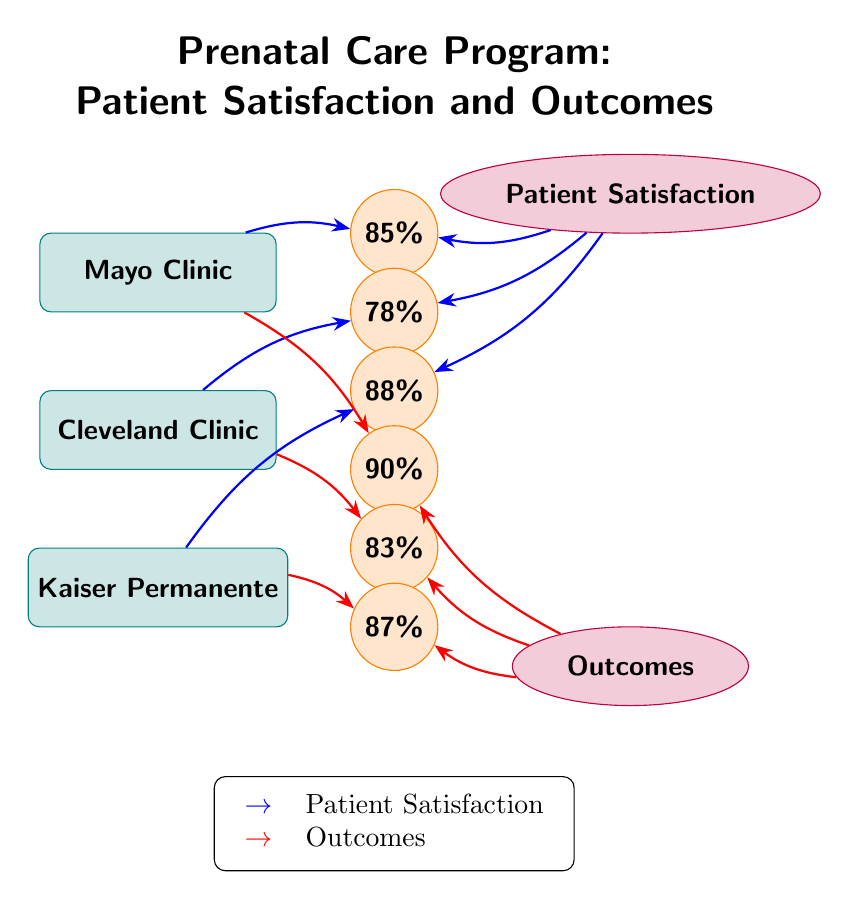What is the patient satisfaction percentage for Mayo Clinic? The diagram indicates that according to the metric for patient satisfaction linked to Mayo Clinic, the satisfaction percentage is represented by the node connected to it. Looking at the node for Mayo Clinic under patient satisfaction shows 85%.
Answer: 85% What is the outcome percentage for Cleveland Clinic? The diagram shows that Cleveland Clinic has a respective outcome percentage linked to it. Referring to the node connected to Cleveland Clinic under outcomes, the percentage noted is 83%.
Answer: 83% Which provider has the highest patient satisfaction? To determine which provider has the highest patient satisfaction, compare the values associated with each provider's satisfaction metric. Mayo Clinic has 85%, Cleveland Clinic has 78%, and Kaiser Permanente has 88%. Kaiser Permanente has the highest percentage.
Answer: Kaiser Permanente How many healthcare providers are represented in this diagram? The diagram displays three healthcare providers represented as nodes. Counting these nodes gives a total of three providers: Mayo Clinic, Cleveland Clinic, and Kaiser Permanente.
Answer: 3 What is the relationship between patient satisfaction and outcomes for Mayo Clinic? The diagram clearly illustrates that the patient satisfaction and outcomes metrics are linked to Mayo Clinic. The satisfaction percentage is 85%, and the outcome percentage is 90%. This indicates both high satisfaction and outcome rates for this provider.
Answer: High Which metric is represented by the blue arrows? The blue arrows in the diagram are used to denote the patient satisfaction metric. They connect each healthcare provider to its corresponding patient satisfaction percentage.
Answer: Patient Satisfaction What percentage of patient satisfaction does Kaiser Permanente have? By referencing the diagram, Kaiser Permanente's patient satisfaction percentage is found to be linked in the satisfaction section showing 88%.
Answer: 88% Which provider has the lowest outcome percentage? To find the provider with the lowest outcome percentage, examine the outcomes associated with each provider: Mayo Clinic has 90%, Cleveland Clinic has 83%, and Kaiser Permanente has 87%. Cleveland Clinic has the lowest percentage.
Answer: Cleveland Clinic 